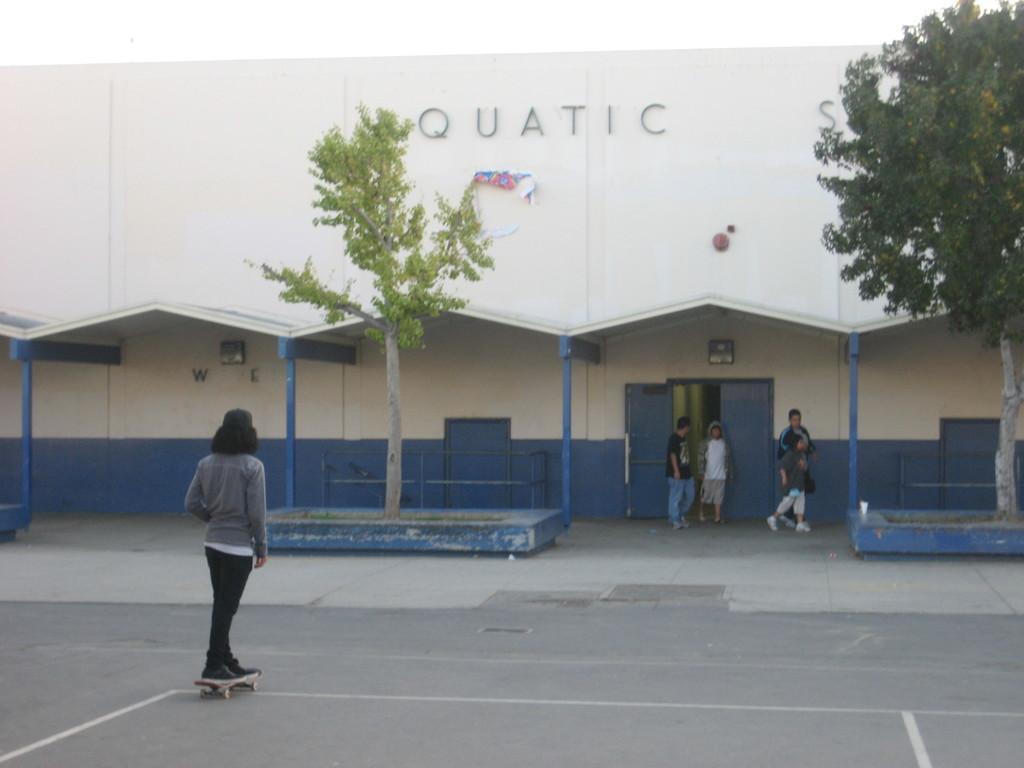In one or two sentences, can you explain what this image depicts? There is a person on a skateboard. In the back there is a building with doors and a pillars. Also there is a name on the building. In front of the building there are trees on stand. Also there are few people near to the doors of the building. 